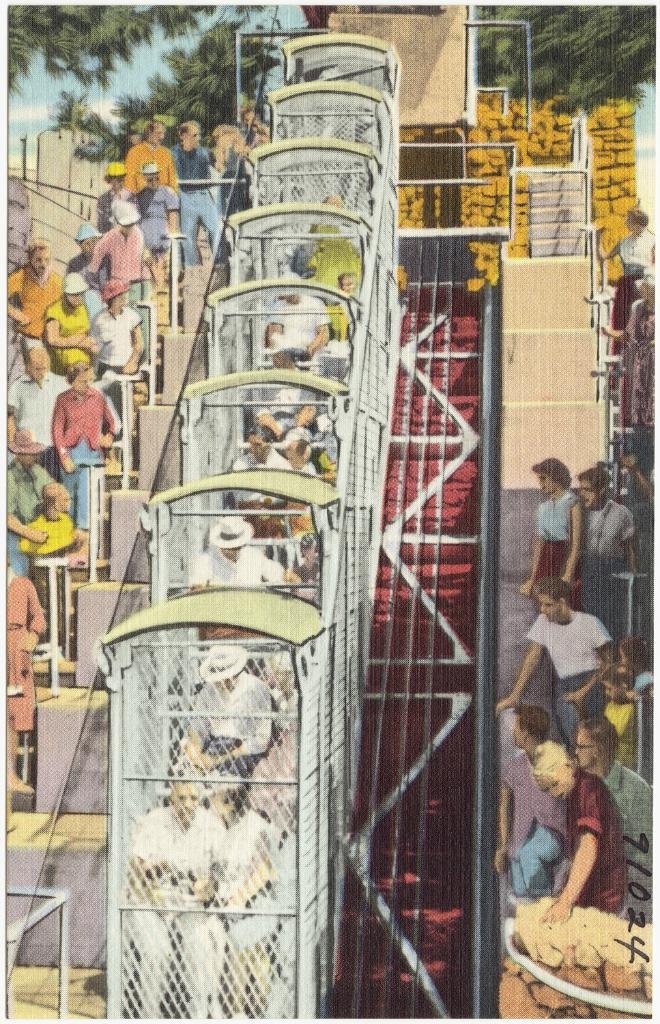What is depicted in the image? The image contains a drawing of people. What architectural feature is included in the drawing? The drawing includes stairs. What type of natural elements are present in the drawing? The drawing includes trees. What part of the natural environment is visible in the drawing? The sky is visible in the drawing. What type of nose can be seen on the monkey in the drawing? There is no monkey present in the drawing; it features a drawing of people with stairs, trees, and a visible sky. 